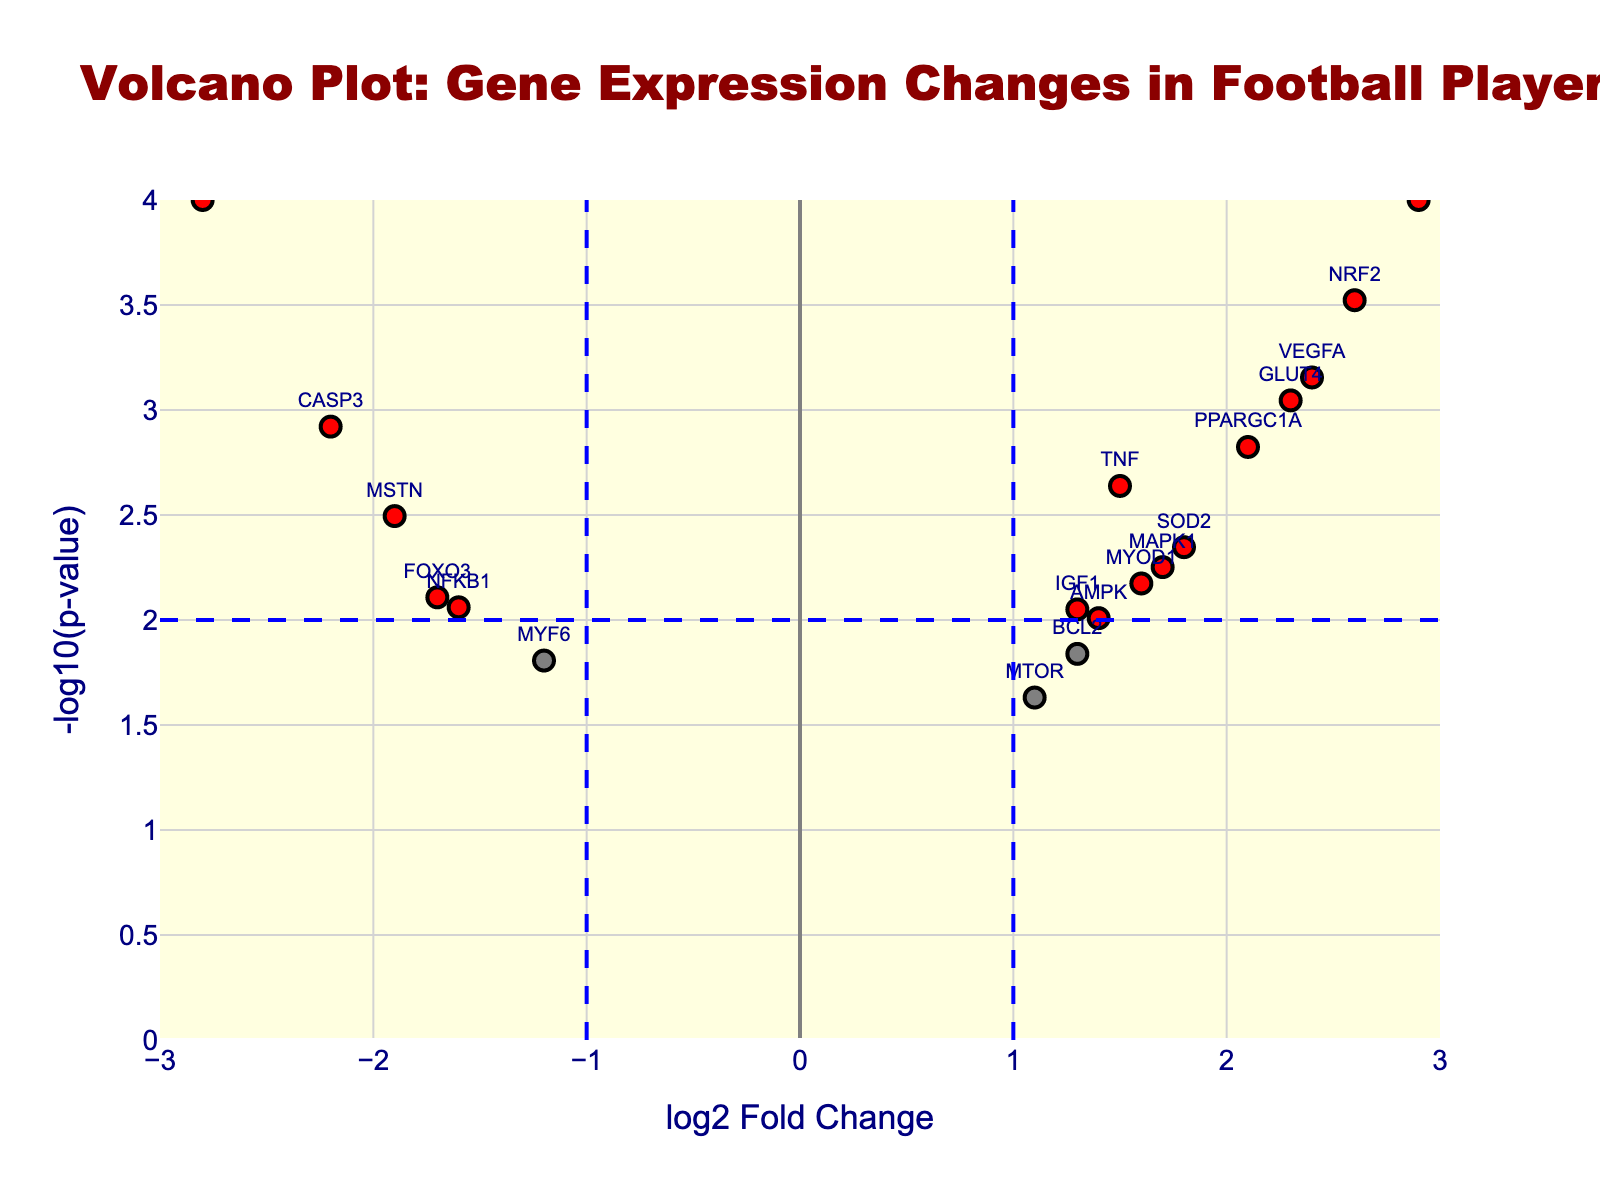What is the title of the volcano plot? The title of the plot is displayed prominently at the top. The figure's title is "Volcano Plot: Gene Expression Changes in Football Players"
Answer: Volcano Plot: Gene Expression Changes in Football Players What do the x-axis and y-axis represent in the plot? The x-axis is labeled "log2 Fold Change," representing the log base 2 of the fold change in gene expression. The y-axis is labeled "-log10(p-value)," representing the negative log base 10 of the p-value for the gene expression changes.
Answer: x-axis: log2 Fold Change, y-axis: -log10(p-value) How many genes showed significant changes according to the plot? Genes with a -log10(p-value) above a certain threshold and an absolute log2 fold change greater than 1 are colored red in the plot. By counting the red points, we see that there are 13 such genes.
Answer: 13 Which gene has the highest increase in expression? The gene at the highest positive x-axis value and the highest y-axis value represents the highest increase in expression. This gene is HSPA1A with a log2FoldChange of 3.2 and a p-value of 0.00005.
Answer: HSPA1A What gene has the greatest decrease in expression? The gene at the highest negative x-axis value and the highest y-axis value represents the greatest decrease in expression. This gene is IL6 with a log2FoldChange of -2.8 and a p-value of 0.0001.
Answer: IL6 How can you distinguish between significant and non-significant gene expression changes in the plot? Significant changes are represented by red points, determined by both a -log10(p-value) greater than a threshold and an absolute log2 fold change greater than 1. Non-significant changes are represented by grey points.
Answer: Red points are significant changes, grey points are not How many genes have a log2 fold change greater than 2? Count the points that are right of the x=2 threshold line. These genes are NRF2, HIF1A, HSPA1A, PPARGC1A, and VEGFA. A total of 5 genes meet this criterion.
Answer: 5 Compare the expressions of TNF and MSTN; which gene is more downregulated? Look at the log2 fold changes: MSTN has a log2FoldChange of -1.9, while TNF has a log2FoldChange of 1.5. MSTN has the more negative value, indicating greater downregulation.
Answer: MSTN Which gene has a higher p-value, MYOD1 or SOD2? Compare the p-values directly: MYOD1 has a p-value of 0.0067 and SOD2 has a p-value of 0.0045. MYOD1 has the higher p-value.
Answer: MYOD1 Are there any genes that are significantly upregulated and have a p-value less than 0.001? Looking for genes colored red and right of the x=1 line with a y-axis (-log10(p-value)) above 3: HSPA1A, NRF2, HIF1A, and VEGFA meet both criteria.
Answer: Yes, HSPA1A, NRF2, HIF1A, VEGFA 